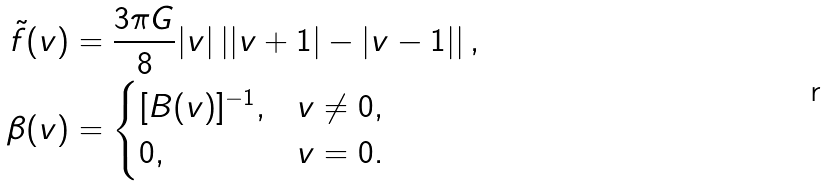Convert formula to latex. <formula><loc_0><loc_0><loc_500><loc_500>\tilde { f } ( v ) & = \frac { 3 \pi G } { 8 } | v | \left | | v + 1 | - | v - 1 | \right | , \\ \beta ( v ) & = \begin{cases} [ B ( v ) ] ^ { - 1 } , & v \neq 0 , \\ 0 , & v = 0 . \end{cases}</formula> 